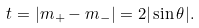<formula> <loc_0><loc_0><loc_500><loc_500>t = | m _ { + } - m _ { - } | = 2 | \sin \theta | .</formula> 